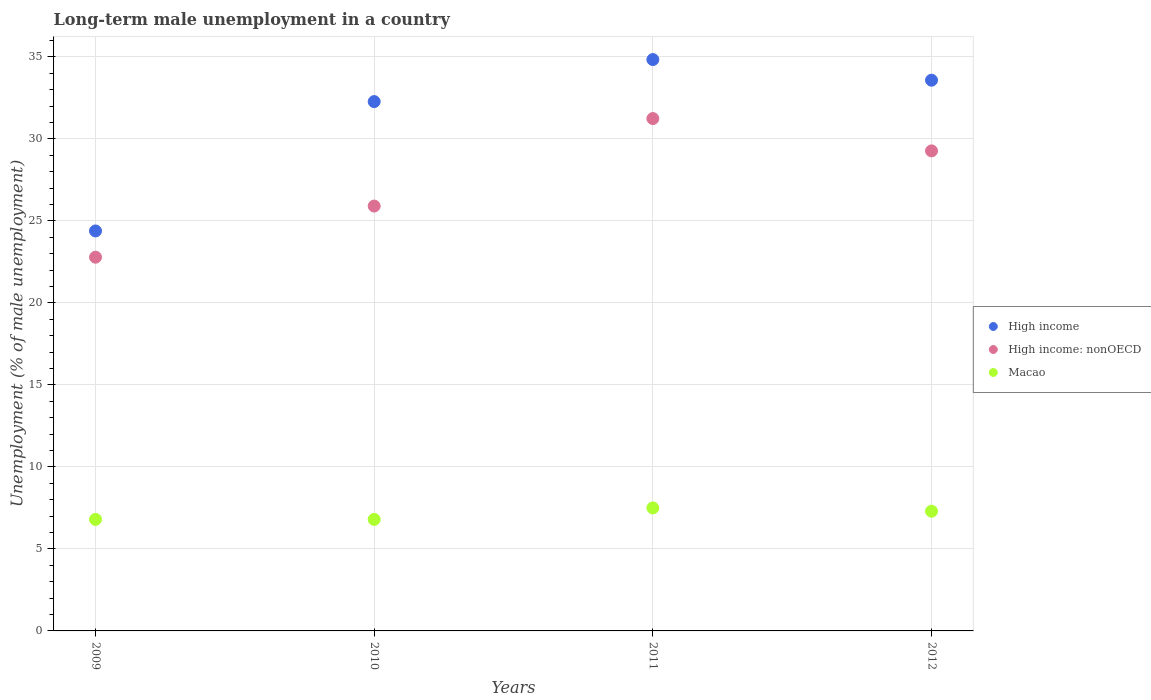How many different coloured dotlines are there?
Provide a short and direct response. 3. Is the number of dotlines equal to the number of legend labels?
Provide a succinct answer. Yes. What is the percentage of long-term unemployed male population in High income: nonOECD in 2010?
Your answer should be compact. 25.91. Across all years, what is the maximum percentage of long-term unemployed male population in High income: nonOECD?
Offer a very short reply. 31.24. Across all years, what is the minimum percentage of long-term unemployed male population in High income?
Offer a very short reply. 24.39. In which year was the percentage of long-term unemployed male population in High income maximum?
Your answer should be very brief. 2011. In which year was the percentage of long-term unemployed male population in Macao minimum?
Keep it short and to the point. 2009. What is the total percentage of long-term unemployed male population in High income in the graph?
Offer a terse response. 125.08. What is the difference between the percentage of long-term unemployed male population in High income in 2009 and that in 2010?
Your response must be concise. -7.89. What is the difference between the percentage of long-term unemployed male population in High income in 2011 and the percentage of long-term unemployed male population in High income: nonOECD in 2009?
Make the answer very short. 12.05. What is the average percentage of long-term unemployed male population in High income: nonOECD per year?
Keep it short and to the point. 27.3. In the year 2010, what is the difference between the percentage of long-term unemployed male population in High income and percentage of long-term unemployed male population in Macao?
Provide a succinct answer. 25.48. What is the ratio of the percentage of long-term unemployed male population in High income: nonOECD in 2011 to that in 2012?
Ensure brevity in your answer.  1.07. Is the percentage of long-term unemployed male population in Macao in 2009 less than that in 2010?
Make the answer very short. No. What is the difference between the highest and the second highest percentage of long-term unemployed male population in Macao?
Keep it short and to the point. 0.2. What is the difference between the highest and the lowest percentage of long-term unemployed male population in High income: nonOECD?
Offer a terse response. 8.45. In how many years, is the percentage of long-term unemployed male population in High income: nonOECD greater than the average percentage of long-term unemployed male population in High income: nonOECD taken over all years?
Give a very brief answer. 2. Is the percentage of long-term unemployed male population in Macao strictly greater than the percentage of long-term unemployed male population in High income: nonOECD over the years?
Ensure brevity in your answer.  No. Is the percentage of long-term unemployed male population in Macao strictly less than the percentage of long-term unemployed male population in High income: nonOECD over the years?
Your answer should be very brief. Yes. How many dotlines are there?
Your answer should be very brief. 3. How many years are there in the graph?
Your response must be concise. 4. Are the values on the major ticks of Y-axis written in scientific E-notation?
Ensure brevity in your answer.  No. Does the graph contain grids?
Your response must be concise. Yes. Where does the legend appear in the graph?
Offer a very short reply. Center right. How many legend labels are there?
Keep it short and to the point. 3. How are the legend labels stacked?
Ensure brevity in your answer.  Vertical. What is the title of the graph?
Keep it short and to the point. Long-term male unemployment in a country. Does "St. Kitts and Nevis" appear as one of the legend labels in the graph?
Provide a short and direct response. No. What is the label or title of the X-axis?
Make the answer very short. Years. What is the label or title of the Y-axis?
Your response must be concise. Unemployment (% of male unemployment). What is the Unemployment (% of male unemployment) of High income in 2009?
Make the answer very short. 24.39. What is the Unemployment (% of male unemployment) of High income: nonOECD in 2009?
Your answer should be very brief. 22.79. What is the Unemployment (% of male unemployment) of Macao in 2009?
Make the answer very short. 6.8. What is the Unemployment (% of male unemployment) of High income in 2010?
Make the answer very short. 32.28. What is the Unemployment (% of male unemployment) of High income: nonOECD in 2010?
Your response must be concise. 25.91. What is the Unemployment (% of male unemployment) of Macao in 2010?
Your answer should be compact. 6.8. What is the Unemployment (% of male unemployment) of High income in 2011?
Your answer should be very brief. 34.84. What is the Unemployment (% of male unemployment) in High income: nonOECD in 2011?
Offer a very short reply. 31.24. What is the Unemployment (% of male unemployment) in High income in 2012?
Offer a terse response. 33.58. What is the Unemployment (% of male unemployment) of High income: nonOECD in 2012?
Offer a terse response. 29.27. What is the Unemployment (% of male unemployment) in Macao in 2012?
Make the answer very short. 7.3. Across all years, what is the maximum Unemployment (% of male unemployment) in High income?
Provide a short and direct response. 34.84. Across all years, what is the maximum Unemployment (% of male unemployment) of High income: nonOECD?
Offer a very short reply. 31.24. Across all years, what is the maximum Unemployment (% of male unemployment) of Macao?
Ensure brevity in your answer.  7.5. Across all years, what is the minimum Unemployment (% of male unemployment) in High income?
Offer a very short reply. 24.39. Across all years, what is the minimum Unemployment (% of male unemployment) in High income: nonOECD?
Your answer should be compact. 22.79. Across all years, what is the minimum Unemployment (% of male unemployment) in Macao?
Provide a succinct answer. 6.8. What is the total Unemployment (% of male unemployment) in High income in the graph?
Offer a very short reply. 125.08. What is the total Unemployment (% of male unemployment) in High income: nonOECD in the graph?
Provide a short and direct response. 109.2. What is the total Unemployment (% of male unemployment) in Macao in the graph?
Offer a very short reply. 28.4. What is the difference between the Unemployment (% of male unemployment) of High income in 2009 and that in 2010?
Your answer should be compact. -7.89. What is the difference between the Unemployment (% of male unemployment) in High income: nonOECD in 2009 and that in 2010?
Provide a succinct answer. -3.12. What is the difference between the Unemployment (% of male unemployment) of Macao in 2009 and that in 2010?
Keep it short and to the point. 0. What is the difference between the Unemployment (% of male unemployment) in High income in 2009 and that in 2011?
Your answer should be compact. -10.45. What is the difference between the Unemployment (% of male unemployment) of High income: nonOECD in 2009 and that in 2011?
Provide a short and direct response. -8.45. What is the difference between the Unemployment (% of male unemployment) of Macao in 2009 and that in 2011?
Provide a short and direct response. -0.7. What is the difference between the Unemployment (% of male unemployment) of High income in 2009 and that in 2012?
Offer a terse response. -9.19. What is the difference between the Unemployment (% of male unemployment) in High income: nonOECD in 2009 and that in 2012?
Offer a terse response. -6.48. What is the difference between the Unemployment (% of male unemployment) in High income in 2010 and that in 2011?
Offer a very short reply. -2.56. What is the difference between the Unemployment (% of male unemployment) in High income: nonOECD in 2010 and that in 2011?
Give a very brief answer. -5.34. What is the difference between the Unemployment (% of male unemployment) of High income in 2010 and that in 2012?
Provide a succinct answer. -1.3. What is the difference between the Unemployment (% of male unemployment) of High income: nonOECD in 2010 and that in 2012?
Give a very brief answer. -3.36. What is the difference between the Unemployment (% of male unemployment) in High income in 2011 and that in 2012?
Ensure brevity in your answer.  1.26. What is the difference between the Unemployment (% of male unemployment) in High income: nonOECD in 2011 and that in 2012?
Your answer should be very brief. 1.97. What is the difference between the Unemployment (% of male unemployment) in High income in 2009 and the Unemployment (% of male unemployment) in High income: nonOECD in 2010?
Provide a succinct answer. -1.52. What is the difference between the Unemployment (% of male unemployment) in High income in 2009 and the Unemployment (% of male unemployment) in Macao in 2010?
Your answer should be compact. 17.59. What is the difference between the Unemployment (% of male unemployment) of High income: nonOECD in 2009 and the Unemployment (% of male unemployment) of Macao in 2010?
Your answer should be very brief. 15.99. What is the difference between the Unemployment (% of male unemployment) in High income in 2009 and the Unemployment (% of male unemployment) in High income: nonOECD in 2011?
Give a very brief answer. -6.85. What is the difference between the Unemployment (% of male unemployment) in High income in 2009 and the Unemployment (% of male unemployment) in Macao in 2011?
Make the answer very short. 16.89. What is the difference between the Unemployment (% of male unemployment) in High income: nonOECD in 2009 and the Unemployment (% of male unemployment) in Macao in 2011?
Make the answer very short. 15.29. What is the difference between the Unemployment (% of male unemployment) of High income in 2009 and the Unemployment (% of male unemployment) of High income: nonOECD in 2012?
Your answer should be very brief. -4.88. What is the difference between the Unemployment (% of male unemployment) of High income in 2009 and the Unemployment (% of male unemployment) of Macao in 2012?
Your answer should be compact. 17.09. What is the difference between the Unemployment (% of male unemployment) in High income: nonOECD in 2009 and the Unemployment (% of male unemployment) in Macao in 2012?
Give a very brief answer. 15.49. What is the difference between the Unemployment (% of male unemployment) of High income in 2010 and the Unemployment (% of male unemployment) of High income: nonOECD in 2011?
Offer a terse response. 1.03. What is the difference between the Unemployment (% of male unemployment) in High income in 2010 and the Unemployment (% of male unemployment) in Macao in 2011?
Ensure brevity in your answer.  24.78. What is the difference between the Unemployment (% of male unemployment) of High income: nonOECD in 2010 and the Unemployment (% of male unemployment) of Macao in 2011?
Offer a terse response. 18.41. What is the difference between the Unemployment (% of male unemployment) in High income in 2010 and the Unemployment (% of male unemployment) in High income: nonOECD in 2012?
Offer a terse response. 3.01. What is the difference between the Unemployment (% of male unemployment) of High income in 2010 and the Unemployment (% of male unemployment) of Macao in 2012?
Your response must be concise. 24.98. What is the difference between the Unemployment (% of male unemployment) in High income: nonOECD in 2010 and the Unemployment (% of male unemployment) in Macao in 2012?
Offer a very short reply. 18.61. What is the difference between the Unemployment (% of male unemployment) in High income in 2011 and the Unemployment (% of male unemployment) in High income: nonOECD in 2012?
Offer a terse response. 5.57. What is the difference between the Unemployment (% of male unemployment) of High income in 2011 and the Unemployment (% of male unemployment) of Macao in 2012?
Give a very brief answer. 27.54. What is the difference between the Unemployment (% of male unemployment) in High income: nonOECD in 2011 and the Unemployment (% of male unemployment) in Macao in 2012?
Keep it short and to the point. 23.94. What is the average Unemployment (% of male unemployment) in High income per year?
Provide a short and direct response. 31.27. What is the average Unemployment (% of male unemployment) of High income: nonOECD per year?
Make the answer very short. 27.3. In the year 2009, what is the difference between the Unemployment (% of male unemployment) of High income and Unemployment (% of male unemployment) of High income: nonOECD?
Make the answer very short. 1.6. In the year 2009, what is the difference between the Unemployment (% of male unemployment) of High income and Unemployment (% of male unemployment) of Macao?
Your answer should be very brief. 17.59. In the year 2009, what is the difference between the Unemployment (% of male unemployment) of High income: nonOECD and Unemployment (% of male unemployment) of Macao?
Offer a terse response. 15.99. In the year 2010, what is the difference between the Unemployment (% of male unemployment) in High income and Unemployment (% of male unemployment) in High income: nonOECD?
Offer a very short reply. 6.37. In the year 2010, what is the difference between the Unemployment (% of male unemployment) of High income and Unemployment (% of male unemployment) of Macao?
Provide a succinct answer. 25.48. In the year 2010, what is the difference between the Unemployment (% of male unemployment) of High income: nonOECD and Unemployment (% of male unemployment) of Macao?
Provide a short and direct response. 19.11. In the year 2011, what is the difference between the Unemployment (% of male unemployment) of High income and Unemployment (% of male unemployment) of High income: nonOECD?
Give a very brief answer. 3.6. In the year 2011, what is the difference between the Unemployment (% of male unemployment) of High income and Unemployment (% of male unemployment) of Macao?
Provide a short and direct response. 27.34. In the year 2011, what is the difference between the Unemployment (% of male unemployment) in High income: nonOECD and Unemployment (% of male unemployment) in Macao?
Give a very brief answer. 23.74. In the year 2012, what is the difference between the Unemployment (% of male unemployment) in High income and Unemployment (% of male unemployment) in High income: nonOECD?
Keep it short and to the point. 4.31. In the year 2012, what is the difference between the Unemployment (% of male unemployment) of High income and Unemployment (% of male unemployment) of Macao?
Your answer should be very brief. 26.28. In the year 2012, what is the difference between the Unemployment (% of male unemployment) in High income: nonOECD and Unemployment (% of male unemployment) in Macao?
Provide a short and direct response. 21.97. What is the ratio of the Unemployment (% of male unemployment) in High income in 2009 to that in 2010?
Offer a terse response. 0.76. What is the ratio of the Unemployment (% of male unemployment) in High income: nonOECD in 2009 to that in 2010?
Your answer should be compact. 0.88. What is the ratio of the Unemployment (% of male unemployment) in Macao in 2009 to that in 2010?
Your answer should be compact. 1. What is the ratio of the Unemployment (% of male unemployment) of High income: nonOECD in 2009 to that in 2011?
Give a very brief answer. 0.73. What is the ratio of the Unemployment (% of male unemployment) in Macao in 2009 to that in 2011?
Offer a very short reply. 0.91. What is the ratio of the Unemployment (% of male unemployment) in High income in 2009 to that in 2012?
Your response must be concise. 0.73. What is the ratio of the Unemployment (% of male unemployment) in High income: nonOECD in 2009 to that in 2012?
Your answer should be very brief. 0.78. What is the ratio of the Unemployment (% of male unemployment) in Macao in 2009 to that in 2012?
Ensure brevity in your answer.  0.93. What is the ratio of the Unemployment (% of male unemployment) of High income in 2010 to that in 2011?
Your answer should be compact. 0.93. What is the ratio of the Unemployment (% of male unemployment) in High income: nonOECD in 2010 to that in 2011?
Offer a terse response. 0.83. What is the ratio of the Unemployment (% of male unemployment) in Macao in 2010 to that in 2011?
Your answer should be very brief. 0.91. What is the ratio of the Unemployment (% of male unemployment) in High income in 2010 to that in 2012?
Your answer should be very brief. 0.96. What is the ratio of the Unemployment (% of male unemployment) in High income: nonOECD in 2010 to that in 2012?
Your response must be concise. 0.89. What is the ratio of the Unemployment (% of male unemployment) in Macao in 2010 to that in 2012?
Provide a short and direct response. 0.93. What is the ratio of the Unemployment (% of male unemployment) of High income in 2011 to that in 2012?
Make the answer very short. 1.04. What is the ratio of the Unemployment (% of male unemployment) in High income: nonOECD in 2011 to that in 2012?
Ensure brevity in your answer.  1.07. What is the ratio of the Unemployment (% of male unemployment) in Macao in 2011 to that in 2012?
Your response must be concise. 1.03. What is the difference between the highest and the second highest Unemployment (% of male unemployment) in High income?
Ensure brevity in your answer.  1.26. What is the difference between the highest and the second highest Unemployment (% of male unemployment) of High income: nonOECD?
Keep it short and to the point. 1.97. What is the difference between the highest and the lowest Unemployment (% of male unemployment) in High income?
Provide a succinct answer. 10.45. What is the difference between the highest and the lowest Unemployment (% of male unemployment) of High income: nonOECD?
Your answer should be very brief. 8.45. What is the difference between the highest and the lowest Unemployment (% of male unemployment) of Macao?
Give a very brief answer. 0.7. 